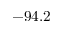Convert formula to latex. <formula><loc_0><loc_0><loc_500><loc_500>- 9 4 . 2</formula> 